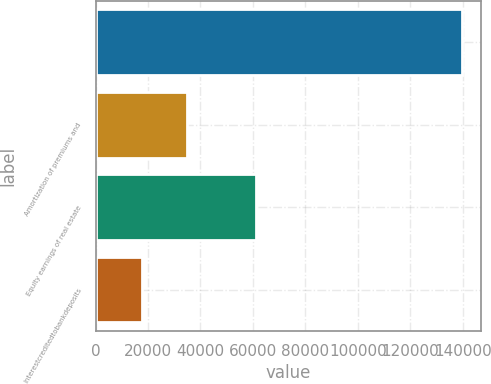Convert chart to OTSL. <chart><loc_0><loc_0><loc_500><loc_500><bar_chart><ecel><fcel>Amortization of premiums and<fcel>Equity earnings of real estate<fcel>Interestcreditedtobankdeposits<nl><fcel>139904<fcel>34997.8<fcel>61224.4<fcel>17513.4<nl></chart> 